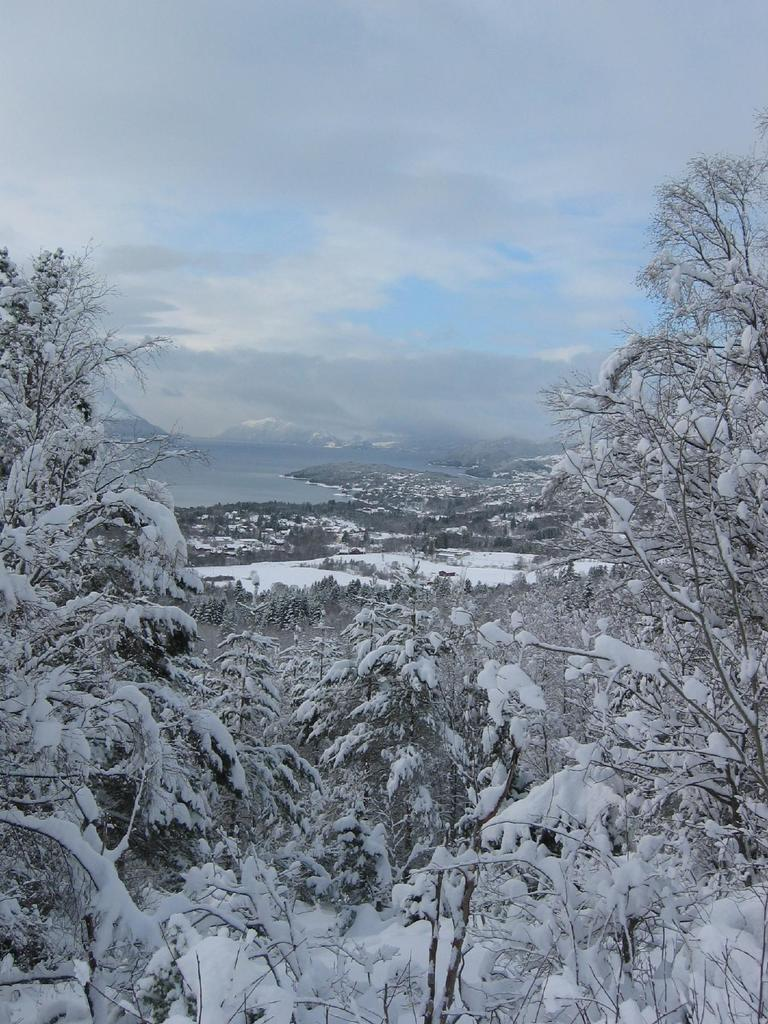What type of vegetation can be seen on both sides of the image? There are trees on the right side and the left side of the image. What is covering the trees in the image? There is snow on the trees. What is visible at the top of the image? The sky is visible at the top of the image. What type of government is depicted in the image? There is no depiction of a government in the image; it features trees with snow on them and a visible sky. How many thrones can be seen in the image? There are no thrones present in the image. 